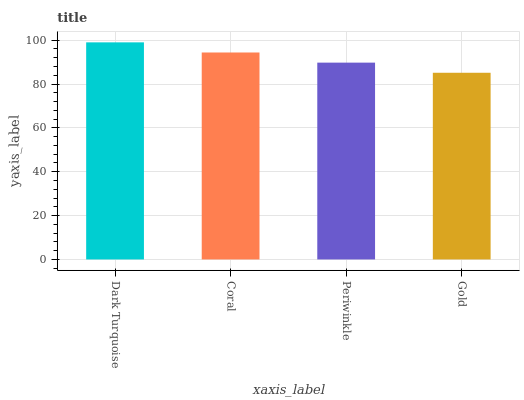Is Gold the minimum?
Answer yes or no. Yes. Is Dark Turquoise the maximum?
Answer yes or no. Yes. Is Coral the minimum?
Answer yes or no. No. Is Coral the maximum?
Answer yes or no. No. Is Dark Turquoise greater than Coral?
Answer yes or no. Yes. Is Coral less than Dark Turquoise?
Answer yes or no. Yes. Is Coral greater than Dark Turquoise?
Answer yes or no. No. Is Dark Turquoise less than Coral?
Answer yes or no. No. Is Coral the high median?
Answer yes or no. Yes. Is Periwinkle the low median?
Answer yes or no. Yes. Is Gold the high median?
Answer yes or no. No. Is Coral the low median?
Answer yes or no. No. 